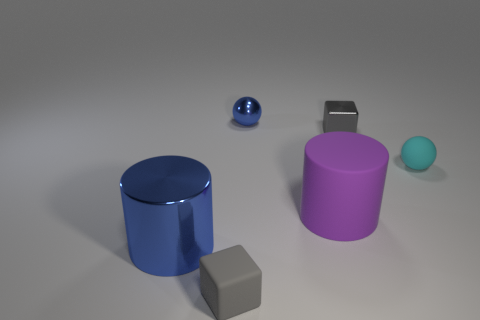What number of other objects are the same shape as the gray metal thing?
Provide a short and direct response. 1. How many things are either large purple rubber things or large cylinders on the right side of the gray rubber object?
Provide a short and direct response. 1. Do the big metallic cylinder and the block to the right of the tiny blue ball have the same color?
Give a very brief answer. No. There is a thing that is on the left side of the large matte cylinder and to the right of the tiny matte block; what is its size?
Provide a short and direct response. Small. There is a tiny metallic block; are there any small metallic spheres in front of it?
Give a very brief answer. No. There is a tiny matte thing in front of the big metallic cylinder; are there any small rubber balls that are in front of it?
Offer a very short reply. No. Are there an equal number of small blocks right of the metal sphere and tiny objects that are in front of the shiny block?
Provide a short and direct response. No. There is a cube that is made of the same material as the purple object; what is its color?
Your response must be concise. Gray. Is there a gray ball made of the same material as the blue ball?
Your answer should be compact. No. What number of objects are either cyan matte things or gray matte things?
Give a very brief answer. 2. 